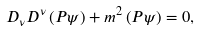Convert formula to latex. <formula><loc_0><loc_0><loc_500><loc_500>D _ { \nu } D ^ { \nu } \left ( P \psi \right ) + m ^ { 2 } \left ( P \psi \right ) = 0 ,</formula> 